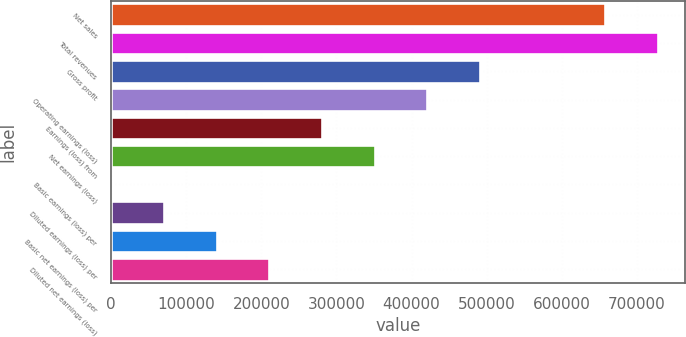<chart> <loc_0><loc_0><loc_500><loc_500><bar_chart><fcel>Net sales<fcel>Total revenues<fcel>Gross profit<fcel>Operating earnings (loss)<fcel>Earnings (loss) from<fcel>Net earnings (loss)<fcel>Basic earnings (loss) per<fcel>Diluted earnings (loss) per<fcel>Basic net earnings (loss) per<fcel>Diluted net earnings (loss)<nl><fcel>657457<fcel>727654<fcel>491380<fcel>421183<fcel>280788<fcel>350986<fcel>0.05<fcel>70197.1<fcel>140394<fcel>210591<nl></chart> 